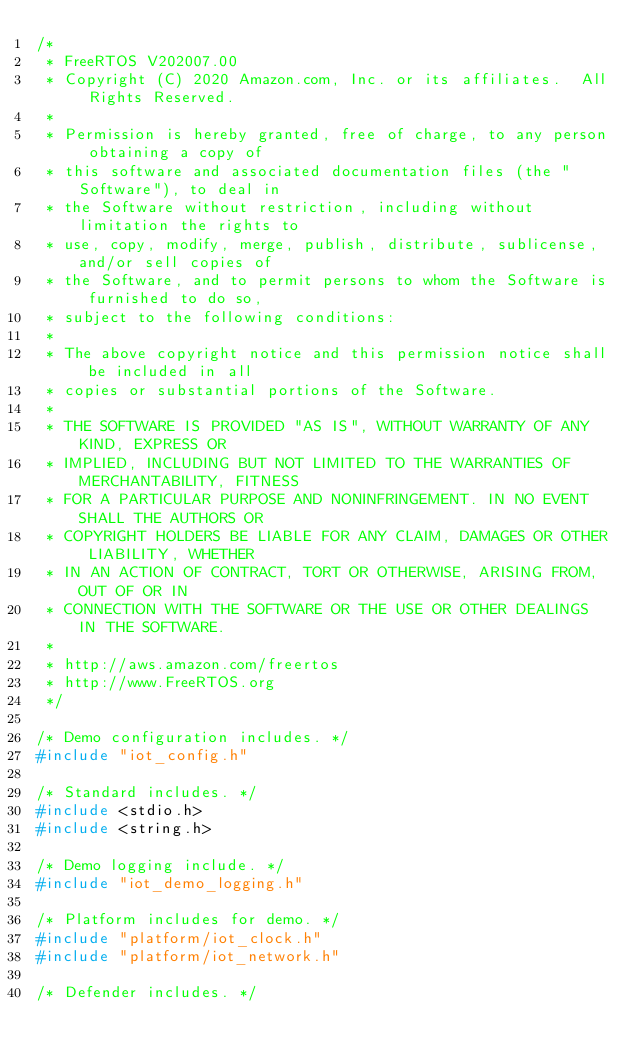Convert code to text. <code><loc_0><loc_0><loc_500><loc_500><_C_>/*
 * FreeRTOS V202007.00
 * Copyright (C) 2020 Amazon.com, Inc. or its affiliates.  All Rights Reserved.
 *
 * Permission is hereby granted, free of charge, to any person obtaining a copy of
 * this software and associated documentation files (the "Software"), to deal in
 * the Software without restriction, including without limitation the rights to
 * use, copy, modify, merge, publish, distribute, sublicense, and/or sell copies of
 * the Software, and to permit persons to whom the Software is furnished to do so,
 * subject to the following conditions:
 *
 * The above copyright notice and this permission notice shall be included in all
 * copies or substantial portions of the Software.
 *
 * THE SOFTWARE IS PROVIDED "AS IS", WITHOUT WARRANTY OF ANY KIND, EXPRESS OR
 * IMPLIED, INCLUDING BUT NOT LIMITED TO THE WARRANTIES OF MERCHANTABILITY, FITNESS
 * FOR A PARTICULAR PURPOSE AND NONINFRINGEMENT. IN NO EVENT SHALL THE AUTHORS OR
 * COPYRIGHT HOLDERS BE LIABLE FOR ANY CLAIM, DAMAGES OR OTHER LIABILITY, WHETHER
 * IN AN ACTION OF CONTRACT, TORT OR OTHERWISE, ARISING FROM, OUT OF OR IN
 * CONNECTION WITH THE SOFTWARE OR THE USE OR OTHER DEALINGS IN THE SOFTWARE.
 *
 * http://aws.amazon.com/freertos
 * http://www.FreeRTOS.org
 */

/* Demo configuration includes. */
#include "iot_config.h"

/* Standard includes. */
#include <stdio.h>
#include <string.h>

/* Demo logging include. */
#include "iot_demo_logging.h"

/* Platform includes for demo. */
#include "platform/iot_clock.h"
#include "platform/iot_network.h"

/* Defender includes. */</code> 